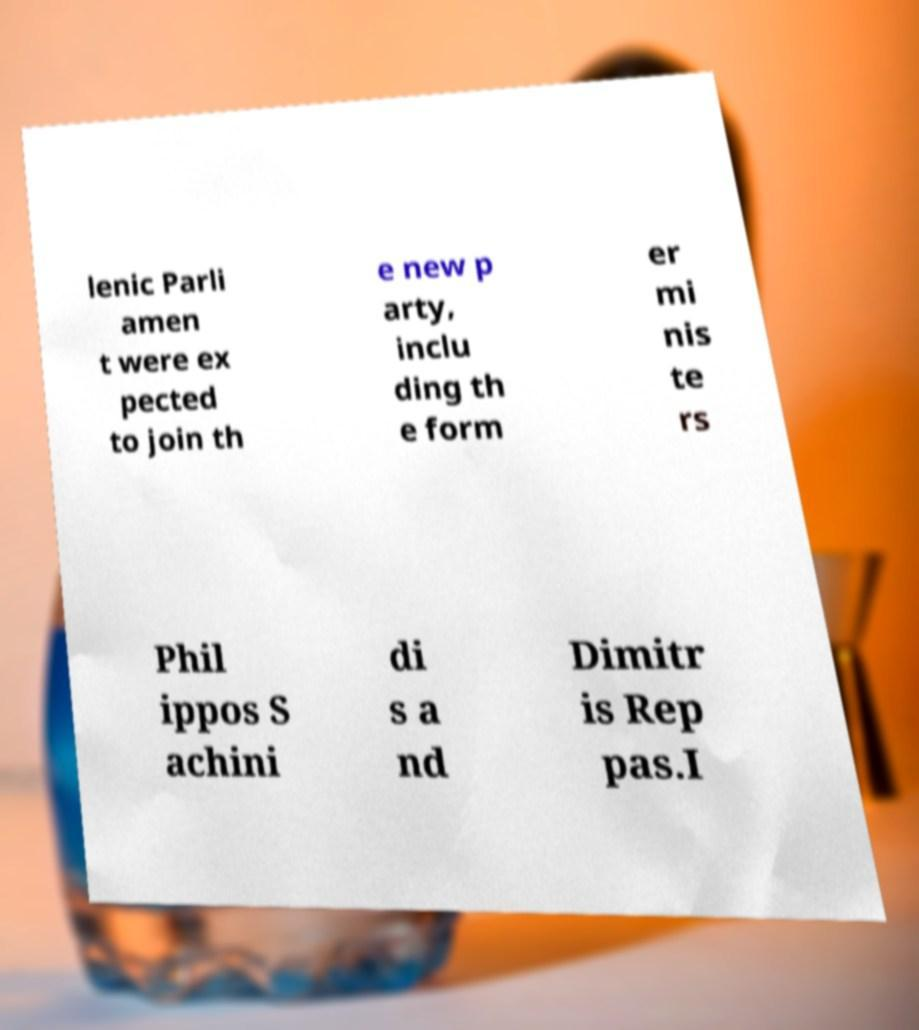I need the written content from this picture converted into text. Can you do that? lenic Parli amen t were ex pected to join th e new p arty, inclu ding th e form er mi nis te rs Phil ippos S achini di s a nd Dimitr is Rep pas.I 